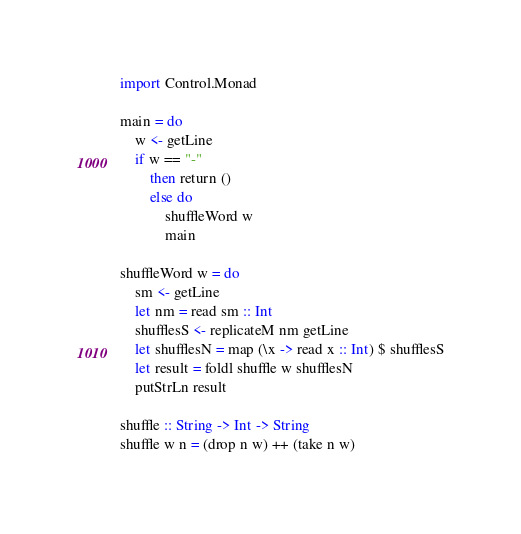Convert code to text. <code><loc_0><loc_0><loc_500><loc_500><_Haskell_>import Control.Monad

main = do
    w <- getLine
    if w == "-"
        then return ()
        else do
            shuffleWord w
            main

shuffleWord w = do
    sm <- getLine
    let nm = read sm :: Int
    shufflesS <- replicateM nm getLine
    let shufflesN = map (\x -> read x :: Int) $ shufflesS
    let result = foldl shuffle w shufflesN
    putStrLn result

shuffle :: String -> Int -> String
shuffle w n = (drop n w) ++ (take n w)
</code> 